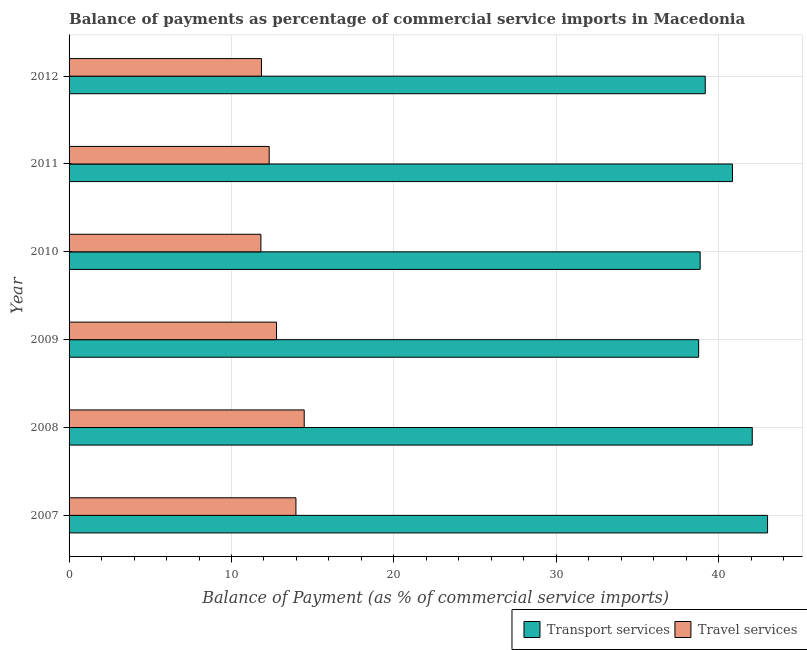Are the number of bars per tick equal to the number of legend labels?
Provide a succinct answer. Yes. How many bars are there on the 5th tick from the bottom?
Offer a terse response. 2. What is the label of the 6th group of bars from the top?
Ensure brevity in your answer.  2007. In how many cases, is the number of bars for a given year not equal to the number of legend labels?
Make the answer very short. 0. What is the balance of payments of travel services in 2011?
Your answer should be very brief. 12.32. Across all years, what is the maximum balance of payments of travel services?
Provide a succinct answer. 14.48. Across all years, what is the minimum balance of payments of transport services?
Your answer should be compact. 38.76. What is the total balance of payments of travel services in the graph?
Offer a terse response. 77.19. What is the difference between the balance of payments of travel services in 2008 and that in 2012?
Your answer should be compact. 2.63. What is the difference between the balance of payments of travel services in 2008 and the balance of payments of transport services in 2010?
Your answer should be compact. -24.38. What is the average balance of payments of travel services per year?
Your answer should be compact. 12.87. In the year 2009, what is the difference between the balance of payments of transport services and balance of payments of travel services?
Your answer should be very brief. 25.99. In how many years, is the balance of payments of travel services greater than 20 %?
Keep it short and to the point. 0. Is the balance of payments of travel services in 2007 less than that in 2009?
Your answer should be compact. No. Is the difference between the balance of payments of travel services in 2008 and 2012 greater than the difference between the balance of payments of transport services in 2008 and 2012?
Your answer should be compact. No. What is the difference between the highest and the second highest balance of payments of travel services?
Give a very brief answer. 0.51. What is the difference between the highest and the lowest balance of payments of transport services?
Give a very brief answer. 4.24. In how many years, is the balance of payments of transport services greater than the average balance of payments of transport services taken over all years?
Give a very brief answer. 3. What does the 1st bar from the top in 2009 represents?
Ensure brevity in your answer.  Travel services. What does the 1st bar from the bottom in 2010 represents?
Make the answer very short. Transport services. How many bars are there?
Offer a terse response. 12. Are all the bars in the graph horizontal?
Provide a short and direct response. Yes. How many years are there in the graph?
Your answer should be very brief. 6. What is the difference between two consecutive major ticks on the X-axis?
Your answer should be compact. 10. Where does the legend appear in the graph?
Your response must be concise. Bottom right. How are the legend labels stacked?
Your answer should be very brief. Horizontal. What is the title of the graph?
Offer a terse response. Balance of payments as percentage of commercial service imports in Macedonia. What is the label or title of the X-axis?
Give a very brief answer. Balance of Payment (as % of commercial service imports). What is the label or title of the Y-axis?
Keep it short and to the point. Year. What is the Balance of Payment (as % of commercial service imports) in Transport services in 2007?
Your response must be concise. 43. What is the Balance of Payment (as % of commercial service imports) of Travel services in 2007?
Ensure brevity in your answer.  13.97. What is the Balance of Payment (as % of commercial service imports) of Transport services in 2008?
Your answer should be compact. 42.06. What is the Balance of Payment (as % of commercial service imports) in Travel services in 2008?
Your response must be concise. 14.48. What is the Balance of Payment (as % of commercial service imports) of Transport services in 2009?
Offer a terse response. 38.76. What is the Balance of Payment (as % of commercial service imports) of Travel services in 2009?
Offer a very short reply. 12.77. What is the Balance of Payment (as % of commercial service imports) in Transport services in 2010?
Offer a very short reply. 38.85. What is the Balance of Payment (as % of commercial service imports) in Travel services in 2010?
Offer a very short reply. 11.81. What is the Balance of Payment (as % of commercial service imports) in Transport services in 2011?
Your response must be concise. 40.84. What is the Balance of Payment (as % of commercial service imports) in Travel services in 2011?
Give a very brief answer. 12.32. What is the Balance of Payment (as % of commercial service imports) in Transport services in 2012?
Keep it short and to the point. 39.17. What is the Balance of Payment (as % of commercial service imports) of Travel services in 2012?
Provide a succinct answer. 11.84. Across all years, what is the maximum Balance of Payment (as % of commercial service imports) in Transport services?
Offer a very short reply. 43. Across all years, what is the maximum Balance of Payment (as % of commercial service imports) in Travel services?
Your answer should be compact. 14.48. Across all years, what is the minimum Balance of Payment (as % of commercial service imports) in Transport services?
Your answer should be very brief. 38.76. Across all years, what is the minimum Balance of Payment (as % of commercial service imports) of Travel services?
Keep it short and to the point. 11.81. What is the total Balance of Payment (as % of commercial service imports) in Transport services in the graph?
Offer a very short reply. 242.68. What is the total Balance of Payment (as % of commercial service imports) of Travel services in the graph?
Provide a short and direct response. 77.19. What is the difference between the Balance of Payment (as % of commercial service imports) of Transport services in 2007 and that in 2008?
Offer a terse response. 0.94. What is the difference between the Balance of Payment (as % of commercial service imports) in Travel services in 2007 and that in 2008?
Your response must be concise. -0.51. What is the difference between the Balance of Payment (as % of commercial service imports) of Transport services in 2007 and that in 2009?
Ensure brevity in your answer.  4.24. What is the difference between the Balance of Payment (as % of commercial service imports) of Travel services in 2007 and that in 2009?
Ensure brevity in your answer.  1.19. What is the difference between the Balance of Payment (as % of commercial service imports) of Transport services in 2007 and that in 2010?
Your answer should be very brief. 4.15. What is the difference between the Balance of Payment (as % of commercial service imports) in Travel services in 2007 and that in 2010?
Offer a terse response. 2.16. What is the difference between the Balance of Payment (as % of commercial service imports) in Transport services in 2007 and that in 2011?
Offer a terse response. 2.16. What is the difference between the Balance of Payment (as % of commercial service imports) in Travel services in 2007 and that in 2011?
Provide a succinct answer. 1.65. What is the difference between the Balance of Payment (as % of commercial service imports) of Transport services in 2007 and that in 2012?
Keep it short and to the point. 3.84. What is the difference between the Balance of Payment (as % of commercial service imports) in Travel services in 2007 and that in 2012?
Give a very brief answer. 2.12. What is the difference between the Balance of Payment (as % of commercial service imports) of Transport services in 2008 and that in 2009?
Offer a terse response. 3.3. What is the difference between the Balance of Payment (as % of commercial service imports) in Travel services in 2008 and that in 2009?
Give a very brief answer. 1.7. What is the difference between the Balance of Payment (as % of commercial service imports) in Transport services in 2008 and that in 2010?
Offer a terse response. 3.21. What is the difference between the Balance of Payment (as % of commercial service imports) in Travel services in 2008 and that in 2010?
Your answer should be compact. 2.67. What is the difference between the Balance of Payment (as % of commercial service imports) in Transport services in 2008 and that in 2011?
Keep it short and to the point. 1.22. What is the difference between the Balance of Payment (as % of commercial service imports) of Travel services in 2008 and that in 2011?
Your response must be concise. 2.16. What is the difference between the Balance of Payment (as % of commercial service imports) of Transport services in 2008 and that in 2012?
Your answer should be very brief. 2.89. What is the difference between the Balance of Payment (as % of commercial service imports) of Travel services in 2008 and that in 2012?
Your answer should be compact. 2.63. What is the difference between the Balance of Payment (as % of commercial service imports) in Transport services in 2009 and that in 2010?
Offer a terse response. -0.09. What is the difference between the Balance of Payment (as % of commercial service imports) of Travel services in 2009 and that in 2010?
Make the answer very short. 0.96. What is the difference between the Balance of Payment (as % of commercial service imports) of Transport services in 2009 and that in 2011?
Provide a short and direct response. -2.08. What is the difference between the Balance of Payment (as % of commercial service imports) of Travel services in 2009 and that in 2011?
Offer a terse response. 0.45. What is the difference between the Balance of Payment (as % of commercial service imports) in Transport services in 2009 and that in 2012?
Your answer should be very brief. -0.41. What is the difference between the Balance of Payment (as % of commercial service imports) in Travel services in 2009 and that in 2012?
Ensure brevity in your answer.  0.93. What is the difference between the Balance of Payment (as % of commercial service imports) of Transport services in 2010 and that in 2011?
Make the answer very short. -1.99. What is the difference between the Balance of Payment (as % of commercial service imports) in Travel services in 2010 and that in 2011?
Provide a short and direct response. -0.51. What is the difference between the Balance of Payment (as % of commercial service imports) of Transport services in 2010 and that in 2012?
Give a very brief answer. -0.31. What is the difference between the Balance of Payment (as % of commercial service imports) in Travel services in 2010 and that in 2012?
Provide a short and direct response. -0.03. What is the difference between the Balance of Payment (as % of commercial service imports) of Transport services in 2011 and that in 2012?
Your answer should be compact. 1.68. What is the difference between the Balance of Payment (as % of commercial service imports) in Travel services in 2011 and that in 2012?
Offer a very short reply. 0.48. What is the difference between the Balance of Payment (as % of commercial service imports) of Transport services in 2007 and the Balance of Payment (as % of commercial service imports) of Travel services in 2008?
Give a very brief answer. 28.53. What is the difference between the Balance of Payment (as % of commercial service imports) of Transport services in 2007 and the Balance of Payment (as % of commercial service imports) of Travel services in 2009?
Provide a succinct answer. 30.23. What is the difference between the Balance of Payment (as % of commercial service imports) in Transport services in 2007 and the Balance of Payment (as % of commercial service imports) in Travel services in 2010?
Your response must be concise. 31.19. What is the difference between the Balance of Payment (as % of commercial service imports) of Transport services in 2007 and the Balance of Payment (as % of commercial service imports) of Travel services in 2011?
Keep it short and to the point. 30.68. What is the difference between the Balance of Payment (as % of commercial service imports) in Transport services in 2007 and the Balance of Payment (as % of commercial service imports) in Travel services in 2012?
Offer a terse response. 31.16. What is the difference between the Balance of Payment (as % of commercial service imports) of Transport services in 2008 and the Balance of Payment (as % of commercial service imports) of Travel services in 2009?
Your response must be concise. 29.29. What is the difference between the Balance of Payment (as % of commercial service imports) of Transport services in 2008 and the Balance of Payment (as % of commercial service imports) of Travel services in 2010?
Your answer should be compact. 30.25. What is the difference between the Balance of Payment (as % of commercial service imports) of Transport services in 2008 and the Balance of Payment (as % of commercial service imports) of Travel services in 2011?
Offer a terse response. 29.74. What is the difference between the Balance of Payment (as % of commercial service imports) of Transport services in 2008 and the Balance of Payment (as % of commercial service imports) of Travel services in 2012?
Ensure brevity in your answer.  30.22. What is the difference between the Balance of Payment (as % of commercial service imports) of Transport services in 2009 and the Balance of Payment (as % of commercial service imports) of Travel services in 2010?
Your response must be concise. 26.95. What is the difference between the Balance of Payment (as % of commercial service imports) in Transport services in 2009 and the Balance of Payment (as % of commercial service imports) in Travel services in 2011?
Keep it short and to the point. 26.44. What is the difference between the Balance of Payment (as % of commercial service imports) of Transport services in 2009 and the Balance of Payment (as % of commercial service imports) of Travel services in 2012?
Your answer should be very brief. 26.92. What is the difference between the Balance of Payment (as % of commercial service imports) in Transport services in 2010 and the Balance of Payment (as % of commercial service imports) in Travel services in 2011?
Your response must be concise. 26.53. What is the difference between the Balance of Payment (as % of commercial service imports) in Transport services in 2010 and the Balance of Payment (as % of commercial service imports) in Travel services in 2012?
Offer a very short reply. 27.01. What is the difference between the Balance of Payment (as % of commercial service imports) in Transport services in 2011 and the Balance of Payment (as % of commercial service imports) in Travel services in 2012?
Provide a succinct answer. 29. What is the average Balance of Payment (as % of commercial service imports) in Transport services per year?
Keep it short and to the point. 40.45. What is the average Balance of Payment (as % of commercial service imports) of Travel services per year?
Keep it short and to the point. 12.87. In the year 2007, what is the difference between the Balance of Payment (as % of commercial service imports) of Transport services and Balance of Payment (as % of commercial service imports) of Travel services?
Make the answer very short. 29.04. In the year 2008, what is the difference between the Balance of Payment (as % of commercial service imports) of Transport services and Balance of Payment (as % of commercial service imports) of Travel services?
Your response must be concise. 27.58. In the year 2009, what is the difference between the Balance of Payment (as % of commercial service imports) of Transport services and Balance of Payment (as % of commercial service imports) of Travel services?
Give a very brief answer. 25.99. In the year 2010, what is the difference between the Balance of Payment (as % of commercial service imports) of Transport services and Balance of Payment (as % of commercial service imports) of Travel services?
Make the answer very short. 27.04. In the year 2011, what is the difference between the Balance of Payment (as % of commercial service imports) of Transport services and Balance of Payment (as % of commercial service imports) of Travel services?
Your answer should be compact. 28.52. In the year 2012, what is the difference between the Balance of Payment (as % of commercial service imports) in Transport services and Balance of Payment (as % of commercial service imports) in Travel services?
Your answer should be compact. 27.32. What is the ratio of the Balance of Payment (as % of commercial service imports) in Transport services in 2007 to that in 2008?
Provide a succinct answer. 1.02. What is the ratio of the Balance of Payment (as % of commercial service imports) in Travel services in 2007 to that in 2008?
Keep it short and to the point. 0.96. What is the ratio of the Balance of Payment (as % of commercial service imports) of Transport services in 2007 to that in 2009?
Make the answer very short. 1.11. What is the ratio of the Balance of Payment (as % of commercial service imports) of Travel services in 2007 to that in 2009?
Your answer should be very brief. 1.09. What is the ratio of the Balance of Payment (as % of commercial service imports) of Transport services in 2007 to that in 2010?
Offer a terse response. 1.11. What is the ratio of the Balance of Payment (as % of commercial service imports) of Travel services in 2007 to that in 2010?
Make the answer very short. 1.18. What is the ratio of the Balance of Payment (as % of commercial service imports) of Transport services in 2007 to that in 2011?
Your answer should be compact. 1.05. What is the ratio of the Balance of Payment (as % of commercial service imports) in Travel services in 2007 to that in 2011?
Offer a terse response. 1.13. What is the ratio of the Balance of Payment (as % of commercial service imports) of Transport services in 2007 to that in 2012?
Your answer should be compact. 1.1. What is the ratio of the Balance of Payment (as % of commercial service imports) of Travel services in 2007 to that in 2012?
Your response must be concise. 1.18. What is the ratio of the Balance of Payment (as % of commercial service imports) of Transport services in 2008 to that in 2009?
Ensure brevity in your answer.  1.09. What is the ratio of the Balance of Payment (as % of commercial service imports) of Travel services in 2008 to that in 2009?
Give a very brief answer. 1.13. What is the ratio of the Balance of Payment (as % of commercial service imports) in Transport services in 2008 to that in 2010?
Your answer should be very brief. 1.08. What is the ratio of the Balance of Payment (as % of commercial service imports) of Travel services in 2008 to that in 2010?
Provide a short and direct response. 1.23. What is the ratio of the Balance of Payment (as % of commercial service imports) of Transport services in 2008 to that in 2011?
Offer a very short reply. 1.03. What is the ratio of the Balance of Payment (as % of commercial service imports) of Travel services in 2008 to that in 2011?
Provide a short and direct response. 1.18. What is the ratio of the Balance of Payment (as % of commercial service imports) in Transport services in 2008 to that in 2012?
Ensure brevity in your answer.  1.07. What is the ratio of the Balance of Payment (as % of commercial service imports) in Travel services in 2008 to that in 2012?
Your answer should be very brief. 1.22. What is the ratio of the Balance of Payment (as % of commercial service imports) of Transport services in 2009 to that in 2010?
Give a very brief answer. 1. What is the ratio of the Balance of Payment (as % of commercial service imports) in Travel services in 2009 to that in 2010?
Your answer should be very brief. 1.08. What is the ratio of the Balance of Payment (as % of commercial service imports) of Transport services in 2009 to that in 2011?
Offer a very short reply. 0.95. What is the ratio of the Balance of Payment (as % of commercial service imports) in Travel services in 2009 to that in 2011?
Make the answer very short. 1.04. What is the ratio of the Balance of Payment (as % of commercial service imports) of Transport services in 2009 to that in 2012?
Offer a terse response. 0.99. What is the ratio of the Balance of Payment (as % of commercial service imports) in Travel services in 2009 to that in 2012?
Your answer should be compact. 1.08. What is the ratio of the Balance of Payment (as % of commercial service imports) in Transport services in 2010 to that in 2011?
Your answer should be very brief. 0.95. What is the ratio of the Balance of Payment (as % of commercial service imports) in Travel services in 2010 to that in 2011?
Your answer should be very brief. 0.96. What is the ratio of the Balance of Payment (as % of commercial service imports) in Transport services in 2010 to that in 2012?
Offer a terse response. 0.99. What is the ratio of the Balance of Payment (as % of commercial service imports) of Travel services in 2010 to that in 2012?
Your answer should be very brief. 1. What is the ratio of the Balance of Payment (as % of commercial service imports) of Transport services in 2011 to that in 2012?
Keep it short and to the point. 1.04. What is the ratio of the Balance of Payment (as % of commercial service imports) in Travel services in 2011 to that in 2012?
Provide a short and direct response. 1.04. What is the difference between the highest and the second highest Balance of Payment (as % of commercial service imports) of Transport services?
Keep it short and to the point. 0.94. What is the difference between the highest and the second highest Balance of Payment (as % of commercial service imports) of Travel services?
Ensure brevity in your answer.  0.51. What is the difference between the highest and the lowest Balance of Payment (as % of commercial service imports) in Transport services?
Provide a short and direct response. 4.24. What is the difference between the highest and the lowest Balance of Payment (as % of commercial service imports) in Travel services?
Your answer should be very brief. 2.67. 